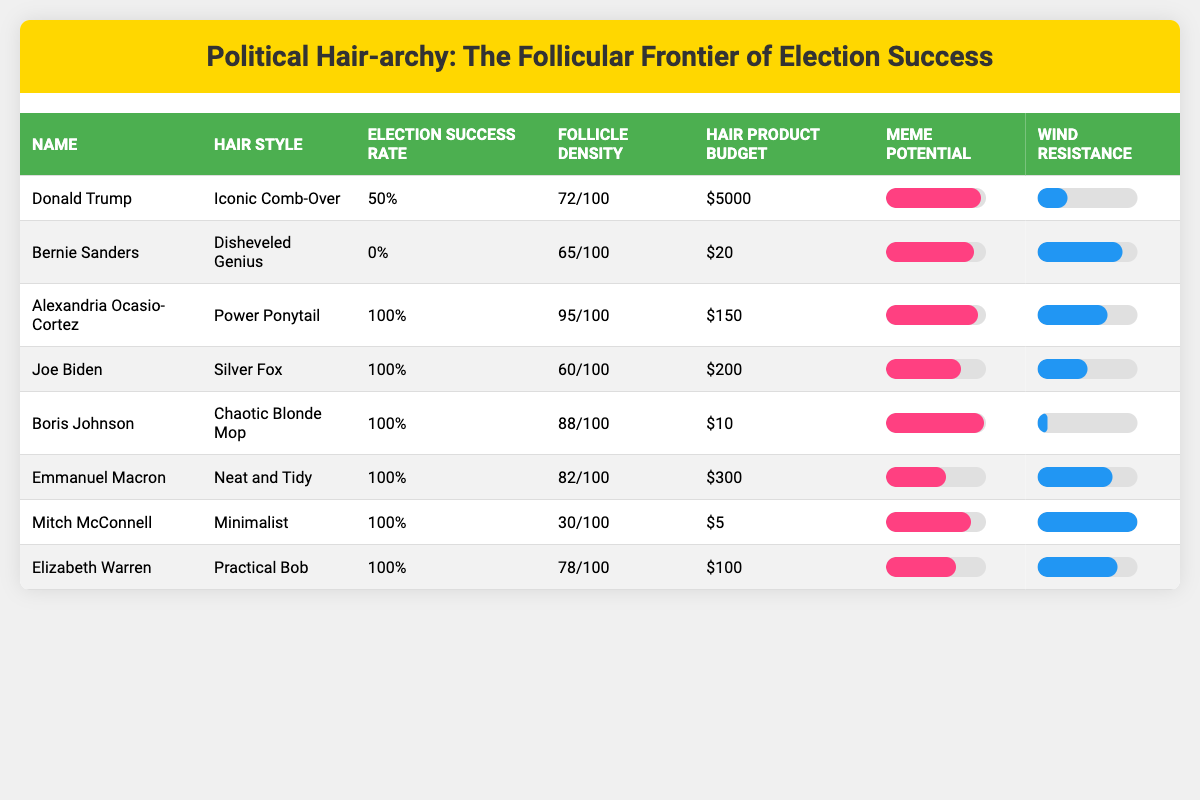What is the hair style of Alexandria Ocasio-Cortez? According to the table, Alexandria Ocasio-Cortez has the hair style "Power Ponytail."
Answer: Power Ponytail Which politician has the highest election success rate? Alexandria Ocasio-Cortez, Joe Biden, Boris Johnson, Emmanuel Macron, Mitch McConnell, and Elizabeth Warren all have an election success rate of 100%, which is the highest among all politicians listed.
Answer: Alexandria Ocasio-Cortez, Joe Biden, Boris Johnson, Emmanuel Macron, Mitch McConnell, Elizabeth Warren What is the average follicle density of the politicians listed? The follicle densities are 72, 65, 95, 60, 88, 82, 30, and 78. Summing these gives 72 + 65 + 95 + 60 + 88 + 82 + 30 + 78 = 570. There are 8 politicians, so the average is 570/8 = 71.25.
Answer: 71.25 Did Bernie Sanders have a higher or lower meme potential compared to Joe Biden? Bernie Sanders' meme potential is 88, while Joe Biden's is 75. Since 88 > 75, Bernie Sanders has a higher meme potential than Joe Biden.
Answer: Higher What is the total budget for hair products for all politicians combined? The hair product budgets are 5000, 20, 150, 200, 10, 300, 5, and 100. Adding these gives 5000 + 20 + 150 + 200 + 10 + 300 + 5 + 100 = 5595.
Answer: 5595 What percentage of politicians have a wind resistance rating lower than 50? Mitch McConnell and Boris Johnson both have wind resistance ratings of 100 and 10, respectively, which are higher. The rest have ratings: 30, 70, 50, 85, 75, and 100. None have lower than 50%, so the percentage is (0/8)*100 = 0%.
Answer: 0% Is there a correlation between hair style complexity and election success rate? Since all politicians with a 100% election success rate have different styles, while the one with a 0% success rate has a disheveled style, it seems hair style complexity doesn't correlate directly with success – further analysis is needed to confirm.
Answer: No direct correlation What is the lowest hair product budget among the politicians? The lowest hair product budget listed is Mitch McConnell's at $5.
Answer: $5 Which hair style has the highest average wind resistance rating? The wind resistance ratings are 30, 85, 70, 50, 10, 75, 100, and 80 for each politician. After calculating the average: (30 + 85 + 70 + 50 + 10 + 75 + 100 + 80) / 8 = 63.75 is the average.
Answer: 63.75 How many politicians have a follicle density greater than 80? The follicle densities are 72, 65, 95, 60, 88, 82, 30, and 78. The densities greater than 80 are 95, 88, and 82, totaling 3 politicians.
Answer: 3 